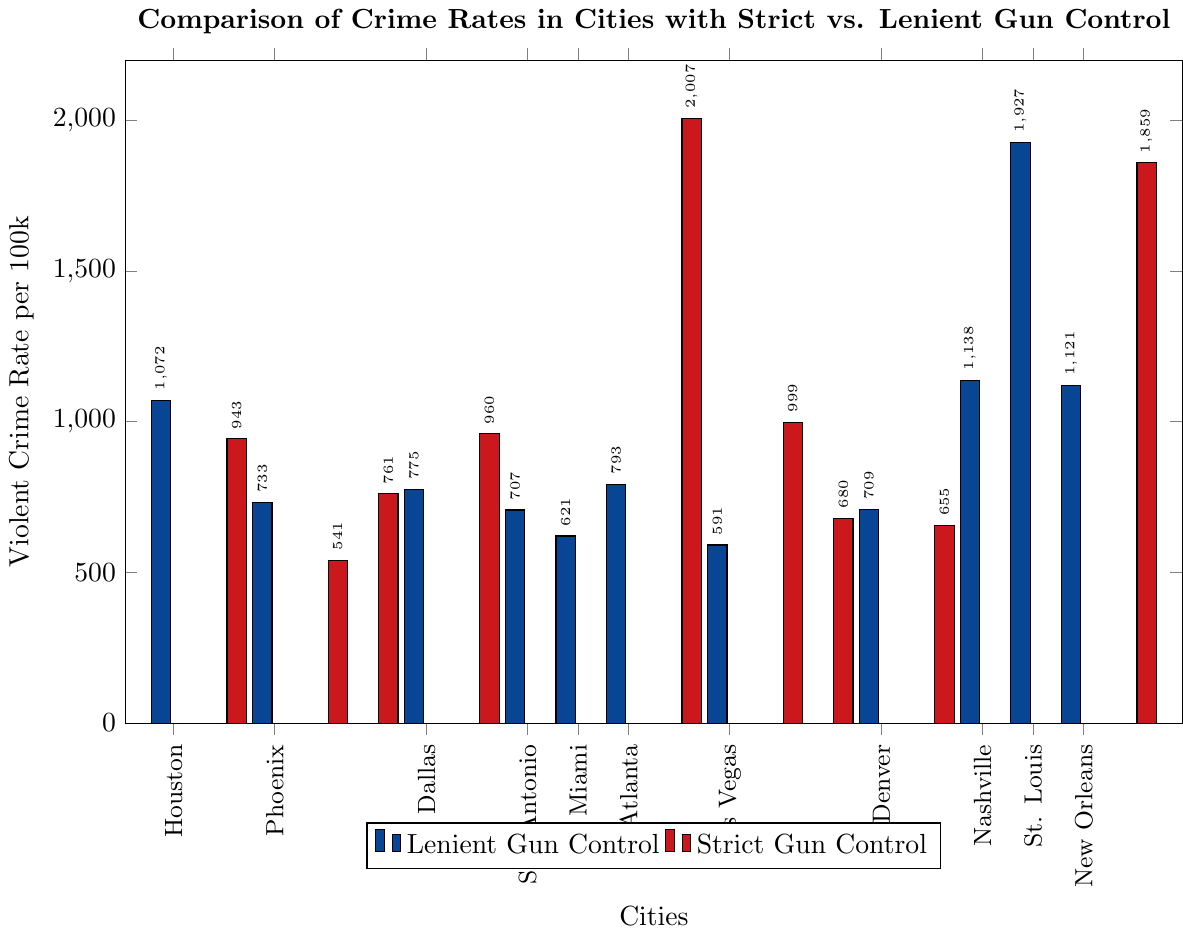What's the violent crime rate in New York City and how does it compare to Miami? The violent crime rate in New York City is represented by a red bar with a height around 541 per 100k, and the rate in Miami is represented by a blue bar with a height around 621 per 100k. Comparing the two, it's evident that New York City has a lower crime rate than Miami.
Answer: New York City: 541, Miami: 621 Which city has the highest violent crime rate among those with strict gun control laws? The plot shows various cities, but Detroit stands out with the tallest red bar, indicating it has the highest violent crime rate at around 2007 per 100k.
Answer: Detroit What is the average violent crime rate for cities with lenient gun control laws? Lenient cities' crime rates are plotted with blue bars. Summing up their rates: (1072 + 733 + 775 + 707 + 621 + 793 + 591 + 709 + 1138 + 1927 + 1121) = 10187, there are 11 cities. Therefore the average is 10187 / 11 ≈ 926.
Answer: 926 Compare the violent crime rates between Baltimore and Dallas. Which city has a lower rate? Baltimore's crime rate is around 1859 per 100k (red bar), while Dallas's rate is around 775 per 100k (blue bar). Clearly, Dallas has a lower violent crime rate than Baltimore.
Answer: Dallas What is the total violent crime rate for the three strict gun control cities with the lowest rates? The cities are New York City (541), Boston (655), and Seattle (680). Summing them gives 541 + 655 + 680 = 1876.
Answer: 1876 If you exclude Detroit, what would be the average violent crime rate for the remaining cities with strict gun control laws? Without Detroit (2007), the remaining cities' rates are (943, 541, 761, 960, 999, 680, 655, 1859). Summing them gives 7398; there are 8 cities. Thus, the average is 7398 / 8 ≈ 925.
Answer: 925 Which city has a higher violent crime rate: St. Louis or Washington DC? St. Louis's crime rate is represented by a blue bar indicating around 1927 per 100k, while Washington DC's red bar stands at about 999 per 100k. Therefore, St. Louis has a higher violent crime rate.
Answer: St. Louis What is the median violent crime rate for the cities with strict gun control laws? The crime rates for strict cities are 943, 541, 761, 960, 2007, 999, 680, 655, 1859. Arranging them in order: 541, 655, 680, 761, 943, 960, 999, 1859, 2007. The median, or the fifth value in this list, is 943.
Answer: 943 How does the violent crime rate of Boston compare to that of Denver? Boston's violent crime rate is represented by a red bar at 655 per 100k while Denver's blue bar stands at 709 per 100k. Thus, Boston has a lower violent crime rate than Denver.
Answer: Boston 